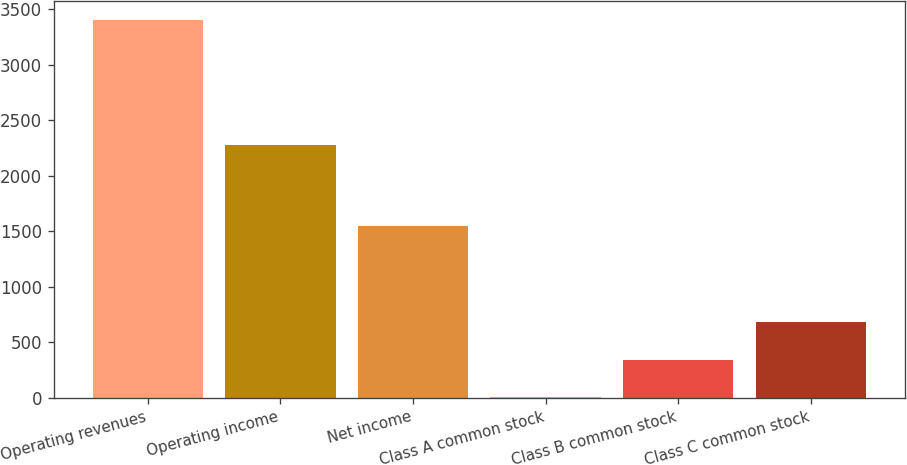Convert chart. <chart><loc_0><loc_0><loc_500><loc_500><bar_chart><fcel>Operating revenues<fcel>Operating income<fcel>Net income<fcel>Class A common stock<fcel>Class B common stock<fcel>Class C common stock<nl><fcel>3409<fcel>2281<fcel>1550<fcel>0.63<fcel>341.47<fcel>682.31<nl></chart> 